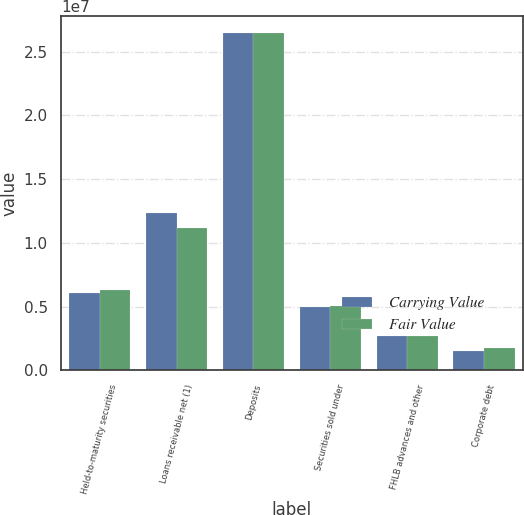<chart> <loc_0><loc_0><loc_500><loc_500><stacked_bar_chart><ecel><fcel>Held-to-maturity securities<fcel>Loans receivable net (1)<fcel>Deposits<fcel>Securities sold under<fcel>FHLB advances and other<fcel>Corporate debt<nl><fcel>Carrying Value<fcel>6.07951e+06<fcel>1.23328e+07<fcel>2.646e+07<fcel>5.0155e+06<fcel>2.73694e+06<fcel>1.49355e+06<nl><fcel>Fair Value<fcel>6.28299e+06<fcel>1.11423e+07<fcel>2.64739e+07<fcel>5.07542e+06<fcel>2.67188e+06<fcel>1.76056e+06<nl></chart> 